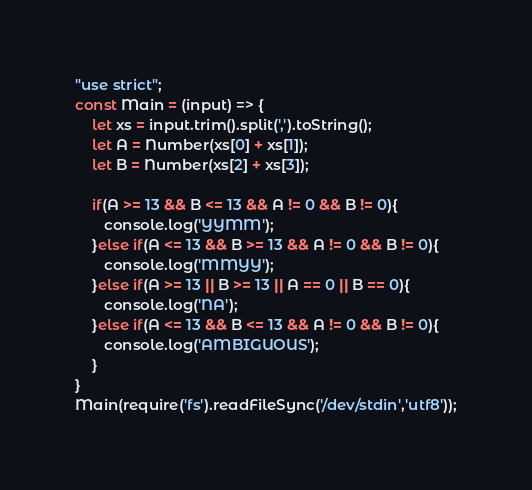Convert code to text. <code><loc_0><loc_0><loc_500><loc_500><_JavaScript_>"use strict";
const Main = (input) => {
	let xs = input.trim().split(',').toString();
    let A = Number(xs[0] + xs[1]);
    let B = Number(xs[2] + xs[3]);
    
    if(A >= 13 && B <= 13 && A != 0 && B != 0){
       console.log('YYMM');
	}else if(A <= 13 && B >= 13 && A != 0 && B != 0){
       console.log('MMYY');
    }else if(A >= 13 || B >= 13 || A == 0 || B == 0){
       console.log('NA');
    }else if(A <= 13 && B <= 13 && A != 0 && B != 0){
       console.log('AMBIGUOUS');
    }
}
Main(require('fs').readFileSync('/dev/stdin','utf8'));</code> 